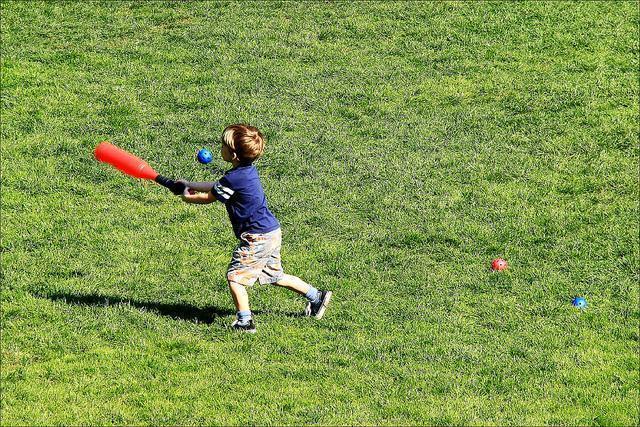Why does the boy have his arms out?
Pick the right solution, then justify: 'Answer: answer
Rationale: rationale.'
Options: Swing, break fall, wave, reach. Answer: swing.
Rationale: He is holding a bat and ready to hit the ball. 